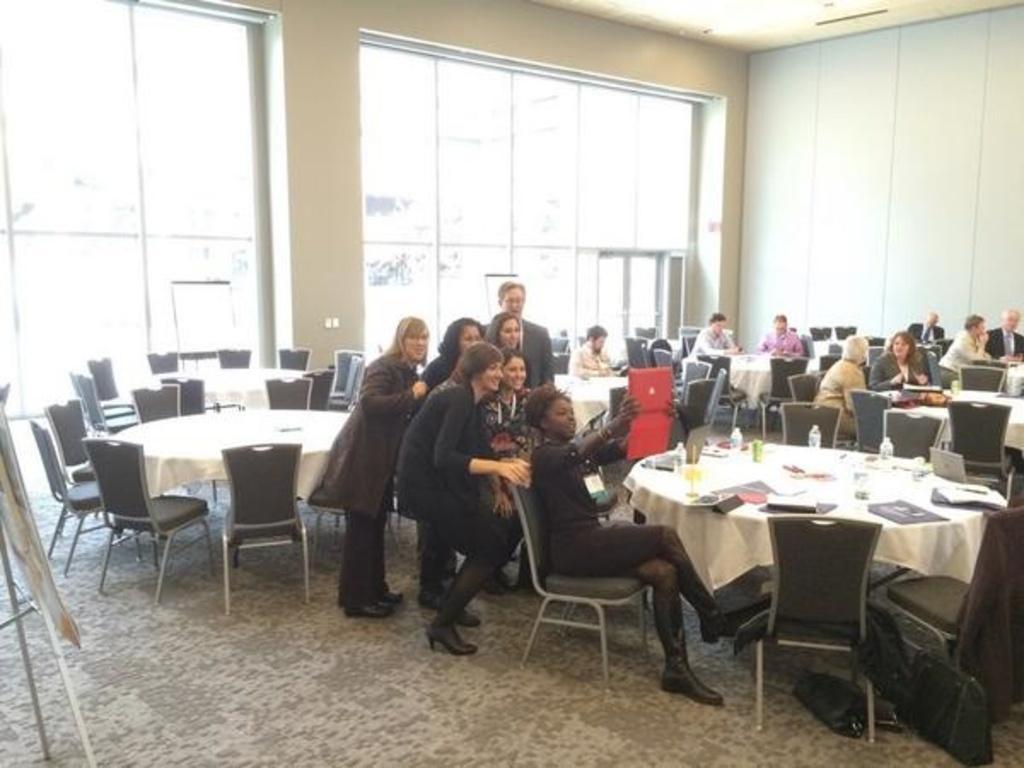Please provide a concise description of this image. There is a woman in black color dress sitting on a chair, capturing image of group of people who are back to her. Beside her, there are laptops, bottles, glasses on the table which is covered with white color cloth. In the background, there is a wall, people sitting around tables, chairs, glass window and other items. 